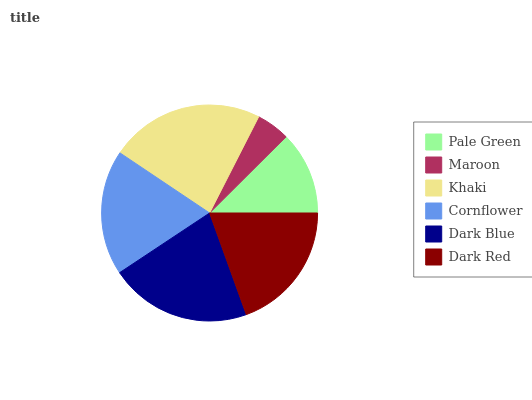Is Maroon the minimum?
Answer yes or no. Yes. Is Khaki the maximum?
Answer yes or no. Yes. Is Khaki the minimum?
Answer yes or no. No. Is Maroon the maximum?
Answer yes or no. No. Is Khaki greater than Maroon?
Answer yes or no. Yes. Is Maroon less than Khaki?
Answer yes or no. Yes. Is Maroon greater than Khaki?
Answer yes or no. No. Is Khaki less than Maroon?
Answer yes or no. No. Is Dark Red the high median?
Answer yes or no. Yes. Is Cornflower the low median?
Answer yes or no. Yes. Is Khaki the high median?
Answer yes or no. No. Is Dark Red the low median?
Answer yes or no. No. 